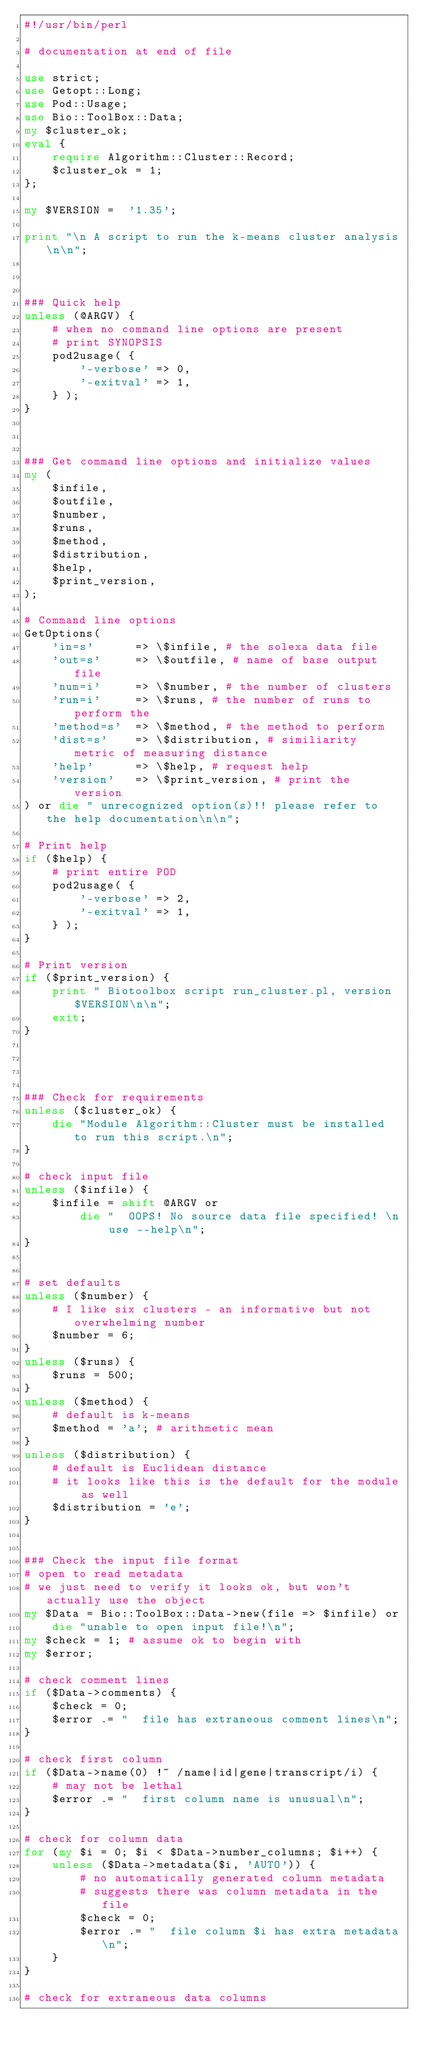Convert code to text. <code><loc_0><loc_0><loc_500><loc_500><_Perl_>#!/usr/bin/perl

# documentation at end of file

use strict;
use Getopt::Long;
use Pod::Usage;
use Bio::ToolBox::Data;
my $cluster_ok;
eval {
	require Algorithm::Cluster::Record;
	$cluster_ok = 1;
};

my $VERSION =  '1.35';

print "\n A script to run the k-means cluster analysis\n\n";



### Quick help
unless (@ARGV) { 
	# when no command line options are present
	# print SYNOPSIS
	pod2usage( {
		'-verbose' => 0, 
		'-exitval' => 1,
	} );
}



### Get command line options and initialize values
my (
	$infile,
	$outfile,
	$number,
	$runs,
	$method,
	$distribution,
	$help,
	$print_version,
);

# Command line options
GetOptions( 
	'in=s'      => \$infile, # the solexa data file
	'out=s'     => \$outfile, # name of base output file 
	'num=i'     => \$number, # the number of clusters
	'run=i'     => \$runs, # the number of runs to perform the
	'method=s'  => \$method, # the method to perform
	'dist=s'    => \$distribution, # similiarity metric of measuring distance
	'help'      => \$help, # request help
	'version'   => \$print_version, # print the version
) or die " unrecognized option(s)!! please refer to the help documentation\n\n";

# Print help
if ($help) {
	# print entire POD
	pod2usage( {
		'-verbose' => 2,
		'-exitval' => 1,
	} );
}

# Print version
if ($print_version) {
	print " Biotoolbox script run_cluster.pl, version $VERSION\n\n";
	exit;
}




### Check for requirements
unless ($cluster_ok) {
	die "Module Algorithm::Cluster must be installed to run this script.\n";
} 

# check input file
unless ($infile) {
	$infile = shift @ARGV or
		die "  OOPS! No source data file specified! \n use --help\n";
}


# set defaults
unless ($number) {
	# I like six clusters - an informative but not overwhelming number
	$number = 6;
}
unless ($runs) {
	$runs = 500;
}
unless ($method) {
	# default is k-means
	$method = 'a'; # arithmetic mean
}
unless ($distribution) {
	# default is Euclidean distance
	# it looks like this is the default for the module as well
	$distribution = 'e';
}


### Check the input file format
# open to read metadata
# we just need to verify it looks ok, but won't actually use the object
my $Data = Bio::ToolBox::Data->new(file => $infile) or 
	die "unable to open input file!\n";
my $check = 1; # assume ok to begin with
my $error;

# check comment lines
if ($Data->comments) {
	$check = 0;
	$error .= "  file has extraneous comment lines\n";
}

# check first column
if ($Data->name(0) !~ /name|id|gene|transcript/i) {
	# may not be lethal
	$error .= "  first column name is unusual\n";
}

# check for column data
for (my $i = 0; $i < $Data->number_columns; $i++) {
	unless ($Data->metadata($i, 'AUTO')) {
		# no automatically generated column metadata 
		# suggests there was column metadata in the file
		$check = 0;
		$error .= "  file column $i has extra metadata\n";
	}
}

# check for extraneous data columns</code> 